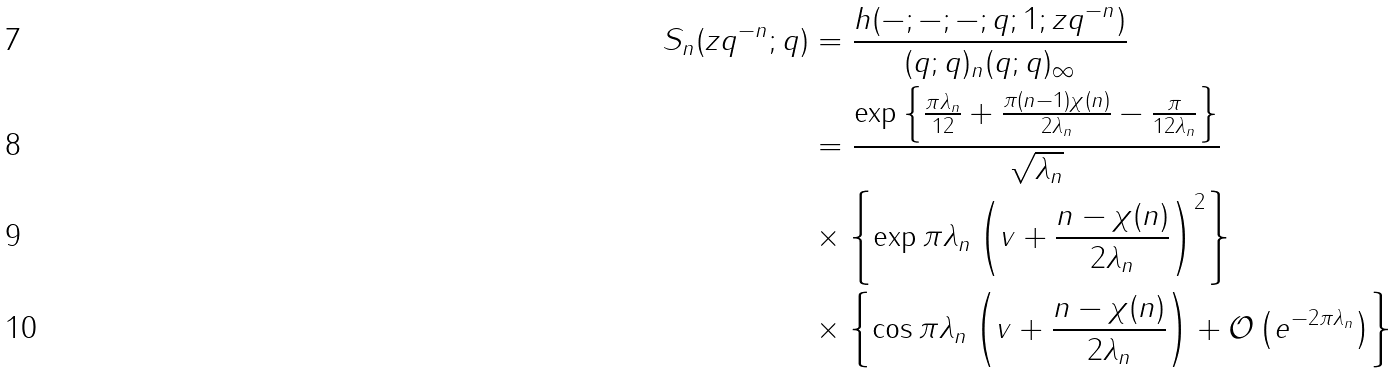<formula> <loc_0><loc_0><loc_500><loc_500>S _ { n } ( z q ^ { - n } ; q ) & = \frac { h ( - ; - ; - ; q ; 1 ; z q ^ { - n } ) } { ( q ; q ) _ { n } ( q ; q ) _ { \infty } } \\ & = \frac { \exp \left \{ \frac { \pi \lambda _ { n } } { 1 2 } + \frac { \pi ( n - 1 ) \chi ( n ) } { 2 \lambda _ { n } } - \frac { \pi } { 1 2 \lambda _ { n } } \right \} } { \sqrt { \lambda _ { n } } } \\ & \times \left \{ \exp \pi \lambda _ { n } \left ( v + \frac { n - \chi ( n ) } { 2 \lambda _ { n } } \right ) ^ { 2 } \right \} \\ & \times \left \{ \cos \pi \lambda _ { n } \left ( v + \frac { n - \chi ( n ) } { 2 \lambda _ { n } } \right ) + \mathcal { O } \left ( e ^ { - 2 \pi \lambda _ { n } } \right ) \right \}</formula> 